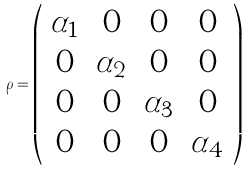Convert formula to latex. <formula><loc_0><loc_0><loc_500><loc_500>\rho = \left ( \begin{array} { c c c c } \alpha _ { 1 } & 0 & 0 & 0 \\ 0 & \alpha _ { 2 } & 0 & 0 \\ 0 & 0 & \alpha _ { 3 } & 0 \\ 0 & 0 & 0 & \alpha _ { 4 } \\ \end{array} \right )</formula> 